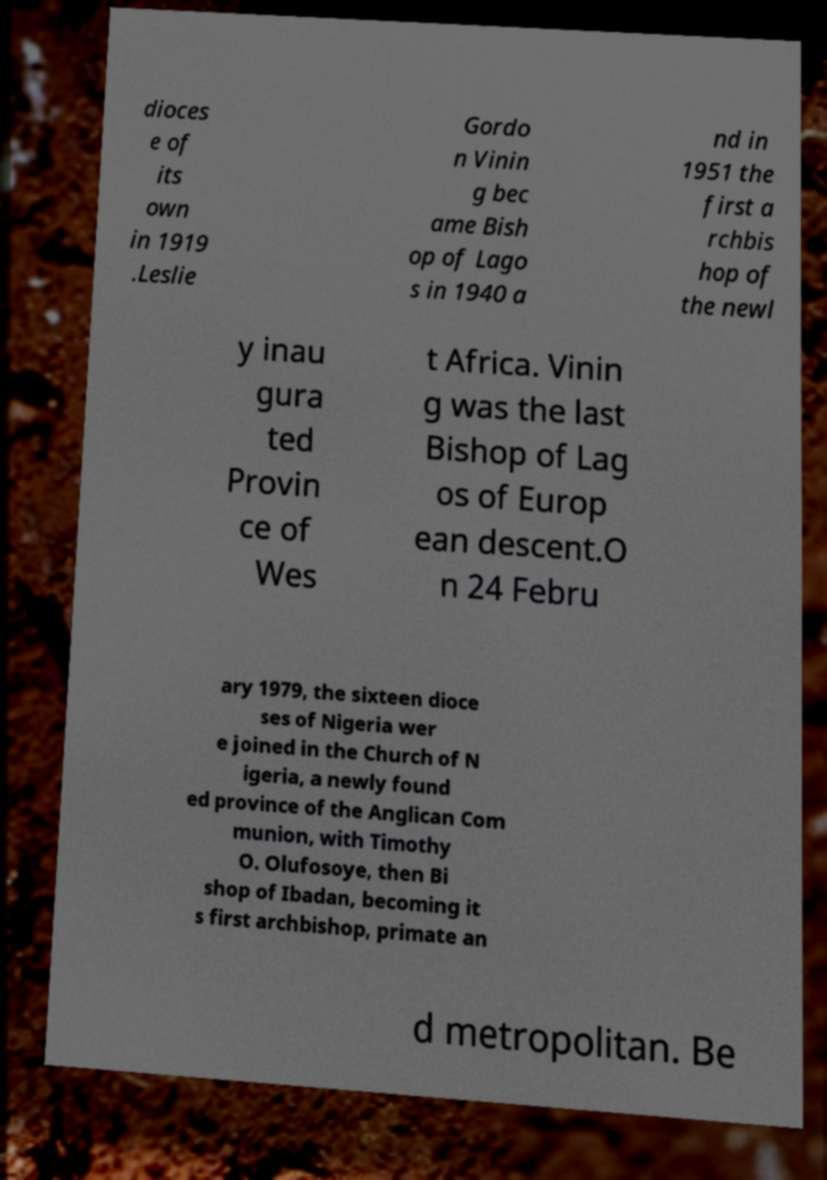For documentation purposes, I need the text within this image transcribed. Could you provide that? dioces e of its own in 1919 .Leslie Gordo n Vinin g bec ame Bish op of Lago s in 1940 a nd in 1951 the first a rchbis hop of the newl y inau gura ted Provin ce of Wes t Africa. Vinin g was the last Bishop of Lag os of Europ ean descent.O n 24 Febru ary 1979, the sixteen dioce ses of Nigeria wer e joined in the Church of N igeria, a newly found ed province of the Anglican Com munion, with Timothy O. Olufosoye, then Bi shop of Ibadan, becoming it s first archbishop, primate an d metropolitan. Be 